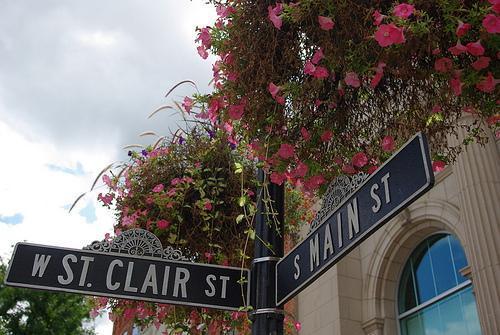How many potted plants are there?
Give a very brief answer. 2. 